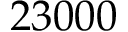<formula> <loc_0><loc_0><loc_500><loc_500>2 3 0 0 0</formula> 